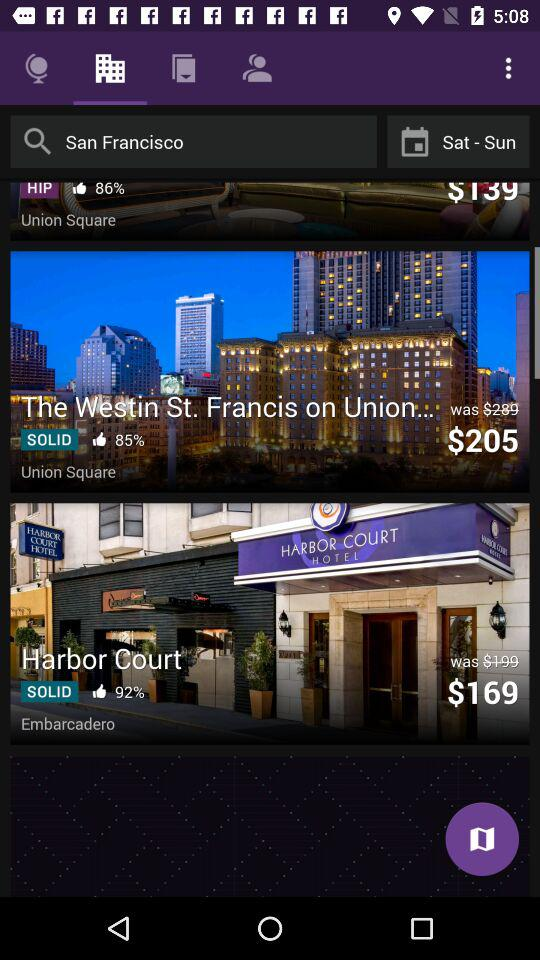What is the percentage of likes for "The Westin St. Francis on Union..."? The percentage of likes is 85. 